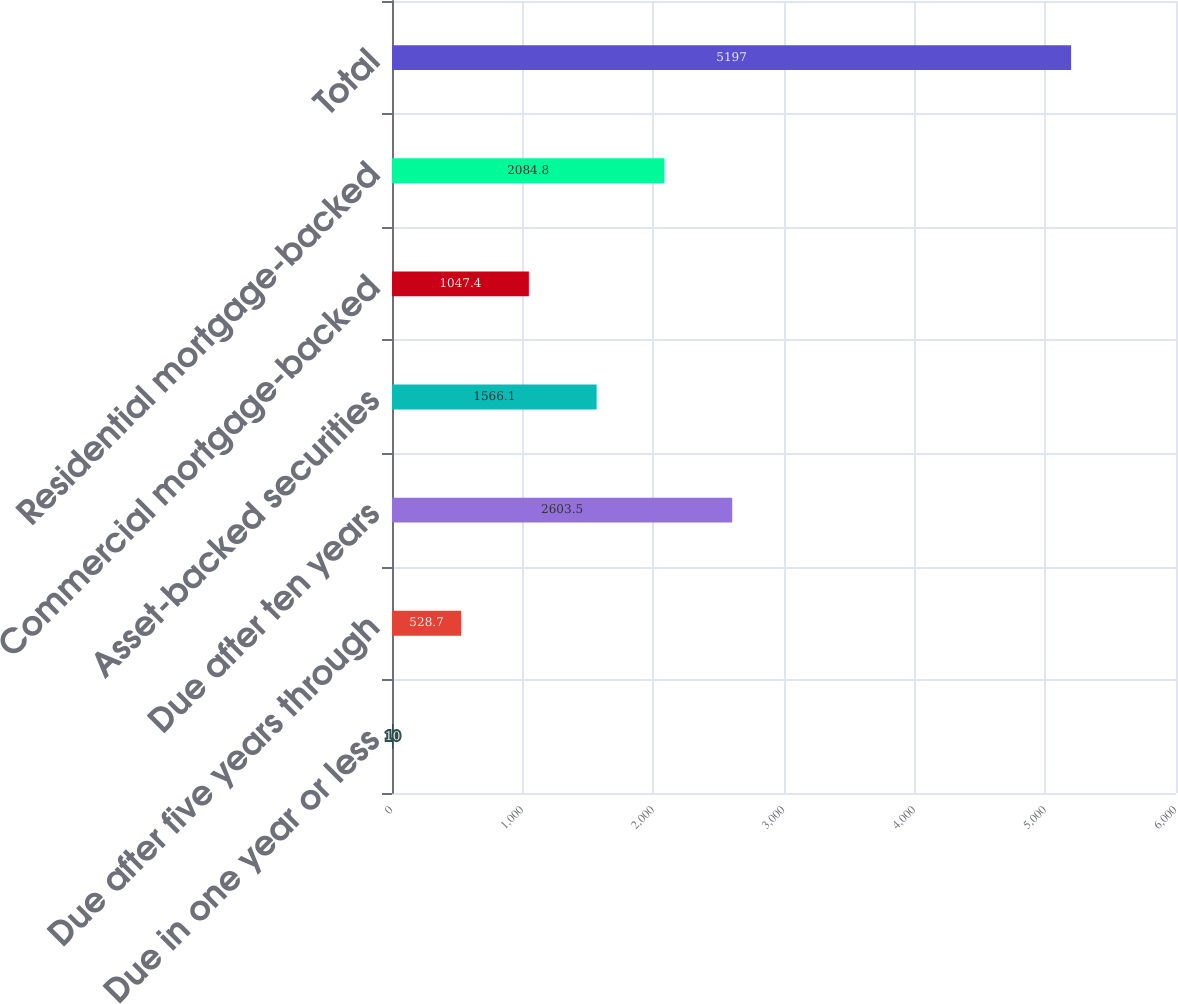Convert chart to OTSL. <chart><loc_0><loc_0><loc_500><loc_500><bar_chart><fcel>Due in one year or less<fcel>Due after five years through<fcel>Due after ten years<fcel>Asset-backed securities<fcel>Commercial mortgage-backed<fcel>Residential mortgage-backed<fcel>Total<nl><fcel>10<fcel>528.7<fcel>2603.5<fcel>1566.1<fcel>1047.4<fcel>2084.8<fcel>5197<nl></chart> 